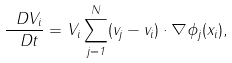<formula> <loc_0><loc_0><loc_500><loc_500>\frac { \ D V _ { i } } { \ D t } = V _ { i } \sum _ { j = 1 } ^ { N } ( v _ { j } - v _ { i } ) \cdot \nabla \phi _ { j } ( x _ { i } ) ,</formula> 